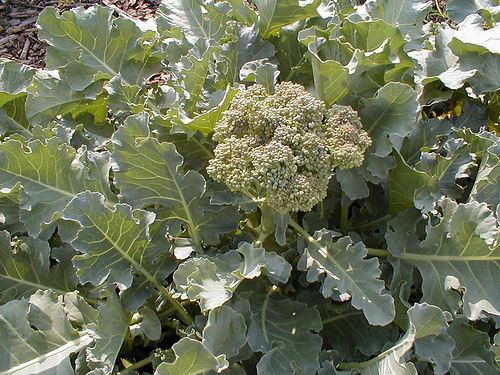What is the color of the leaves?
Be succinct. Green. Is the plant wet?
Short answer required. No. Is this ready to eat?
Write a very short answer. No. Is this a potted plant?
Give a very brief answer. No. What type of plants are these?
Short answer required. Broccoli. 